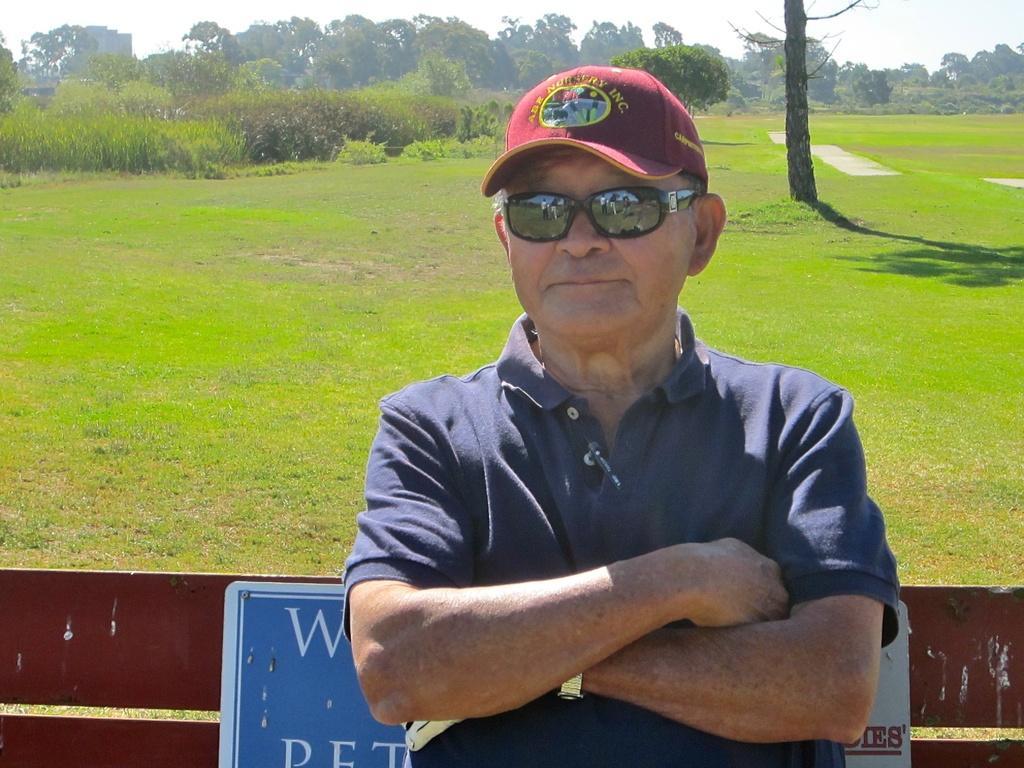In one or two sentences, can you explain what this image depicts? In the center of the image there is a person sitting on the bench. In the background there is a grass, trees, plants and sky. 